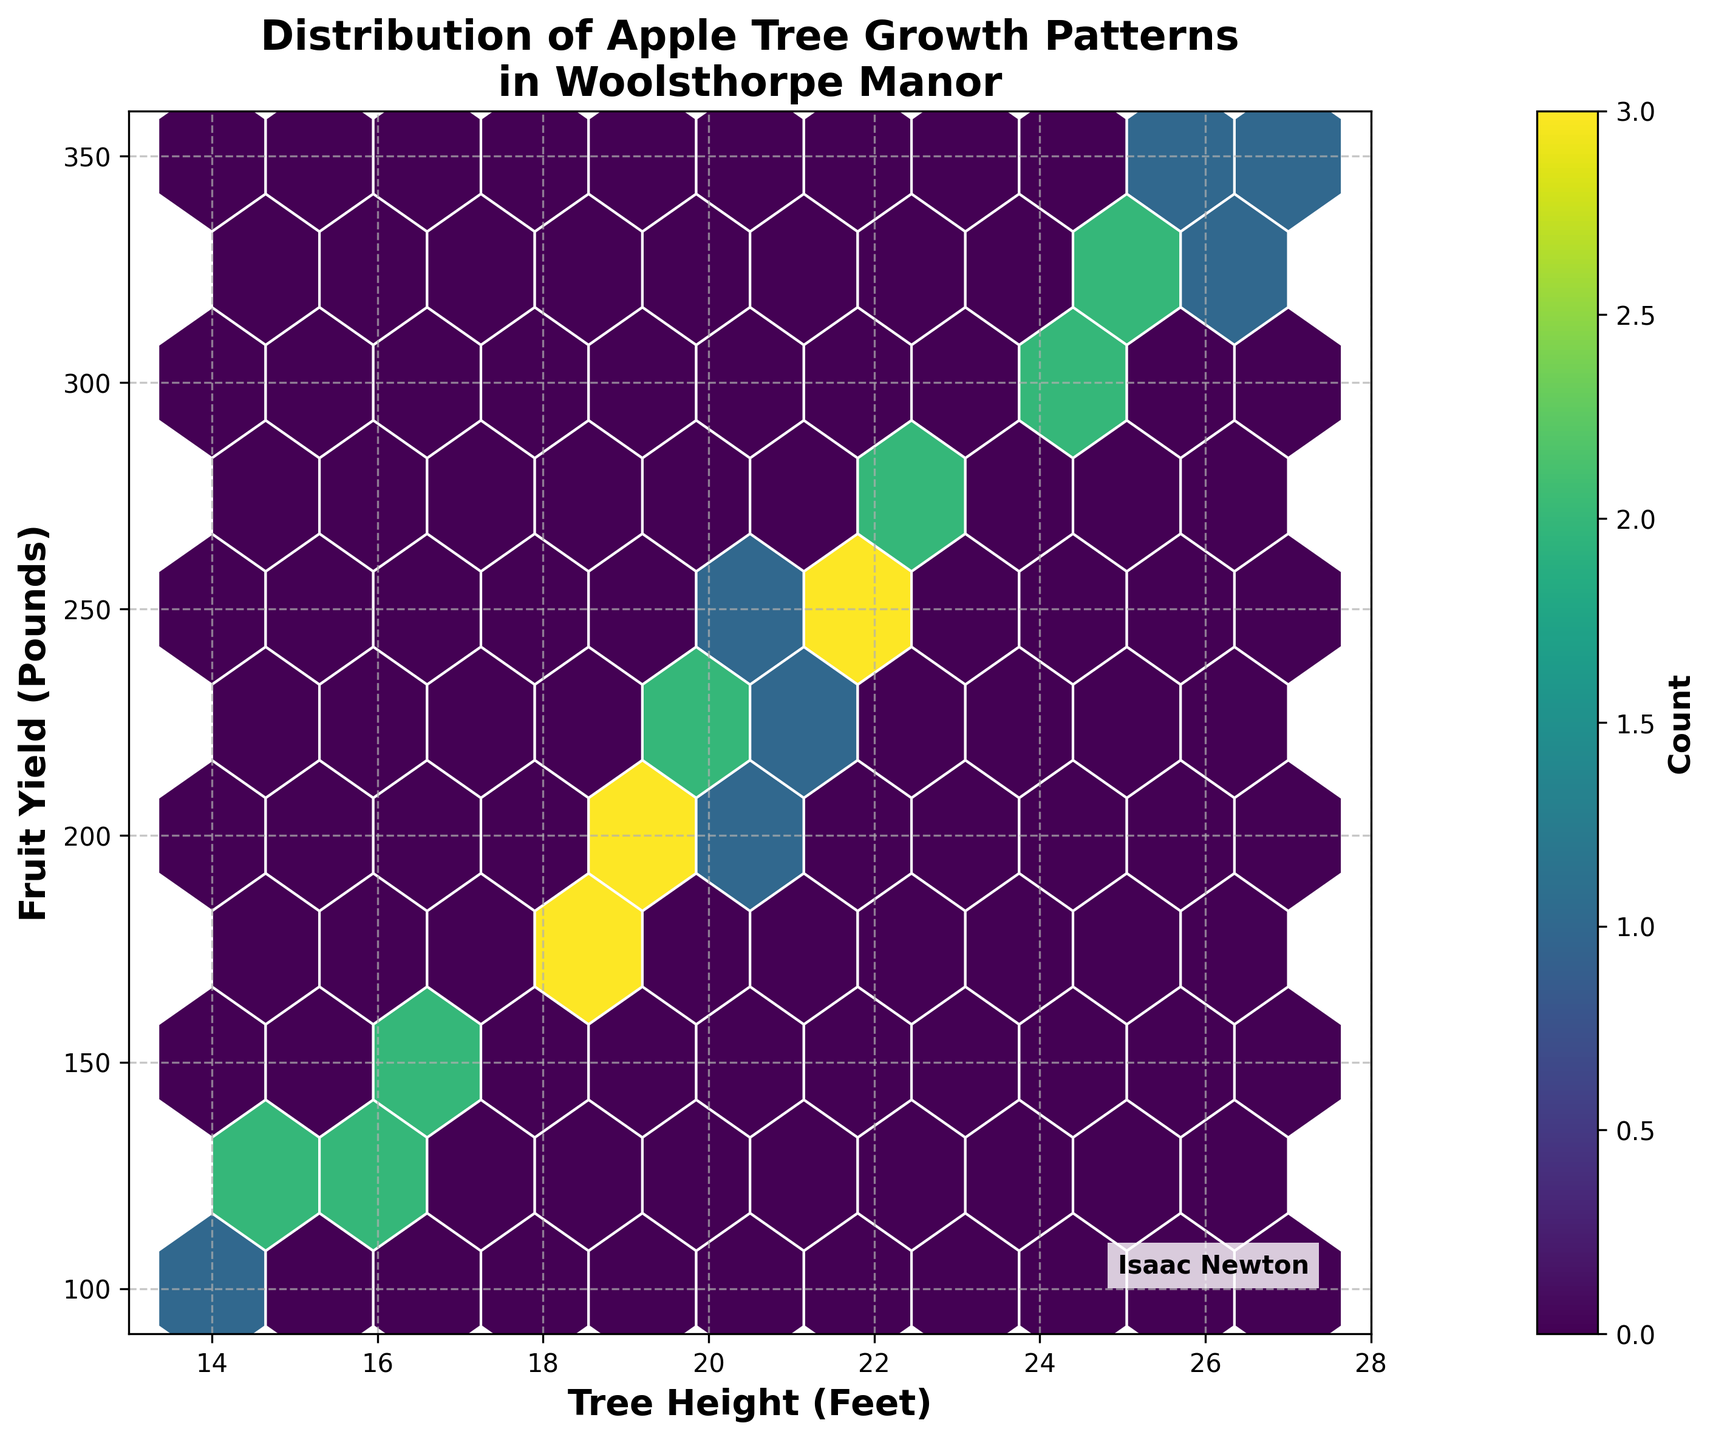How many data points are densely clustered in the hexagon with the highest count? Observe the color bar and the hexagon color indicating the densest cluster; note the corresponding count from the color gradient.
Answer: Approximately 3-4 data points What is the range of the tree height axis on the hexbin plot? Note the minimum and maximum values marked on the x-axis labeled 'Tree Height (Feet)'.
Answer: 13 to 28 feet For which tree height range do most apple trees fall, based on hexagon density? Identify hexagons with the darkest colors indicating highest density on the x-axis range.
Answer: 18 to 22 feet Does fruit yield generally increase with tree height? Examine the trend of hexagon concentration from lower left to upper right.
Answer: Yes, generally What is the fruit yield range for the densest hexagons? Refer to densest hexagons' positions on the y-axis labeled 'Fruit Yield (Pounds)'.
Answer: 160 to 180 pounds What is the color of the hexagons with the lowest counts? Identify the lightest hexagon color from the plot and compare it with the color bar.
Answer: Light yellow In the hexbin plot, are there more apple trees with a height above 20 feet or below 20 feet? Compare the density of hexagons left (below 20 feet) and right (above 20 feet) of the 20 feet mark.
Answer: Below 20 feet Which range of fruit yield is associated with tree heights from 21 to 24 feet? Observe the positions of hexagons within the 21-24 feet tree height range on the y-axis.
Answer: 230 to 300 pounds What is the title of the hexbin plot? Read the text displayed at the top of the plot.
Answer: Distribution of Apple Tree Growth Patterns in Woolsthorpe Manor How does the color bar assist in understanding the hexbin plot's data distribution? The color bar gives a visual reference for the count associated with each hexagon's color, indicating density of data points.
Answer: It indicates the count of data points 